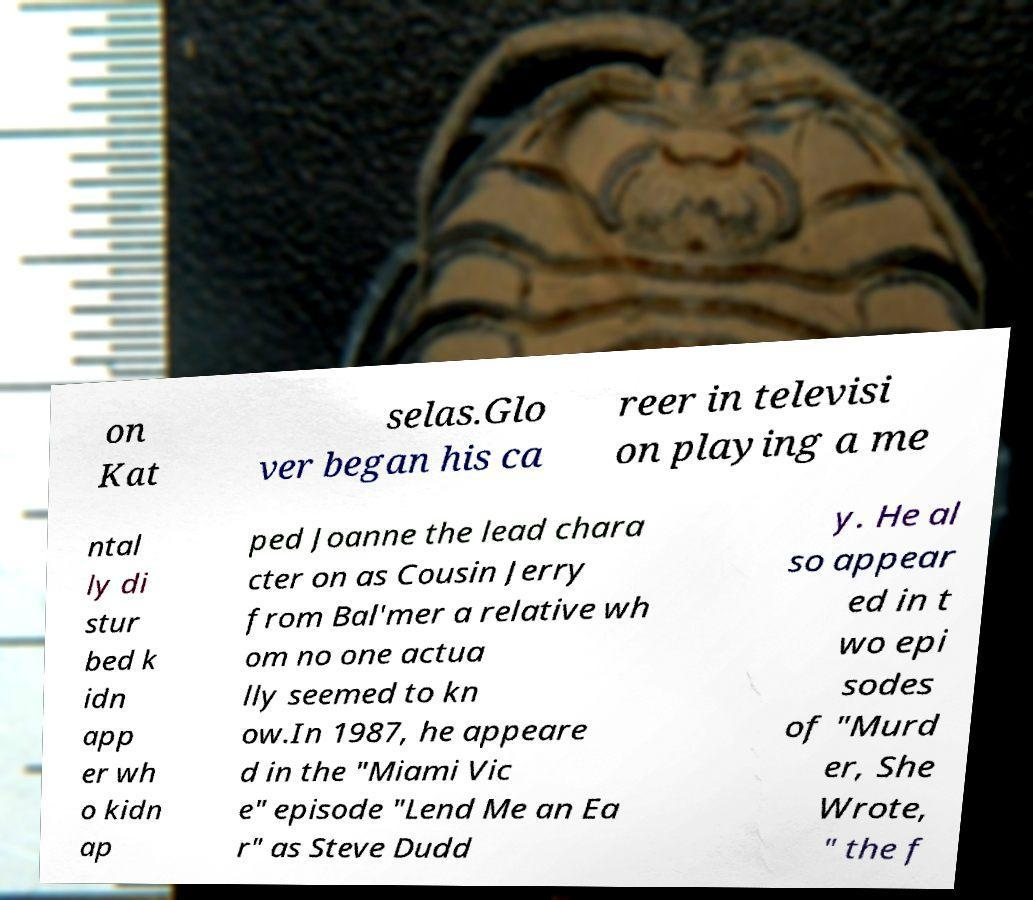Can you read and provide the text displayed in the image?This photo seems to have some interesting text. Can you extract and type it out for me? on Kat selas.Glo ver began his ca reer in televisi on playing a me ntal ly di stur bed k idn app er wh o kidn ap ped Joanne the lead chara cter on as Cousin Jerry from Bal'mer a relative wh om no one actua lly seemed to kn ow.In 1987, he appeare d in the "Miami Vic e" episode "Lend Me an Ea r" as Steve Dudd y. He al so appear ed in t wo epi sodes of "Murd er, She Wrote, " the f 